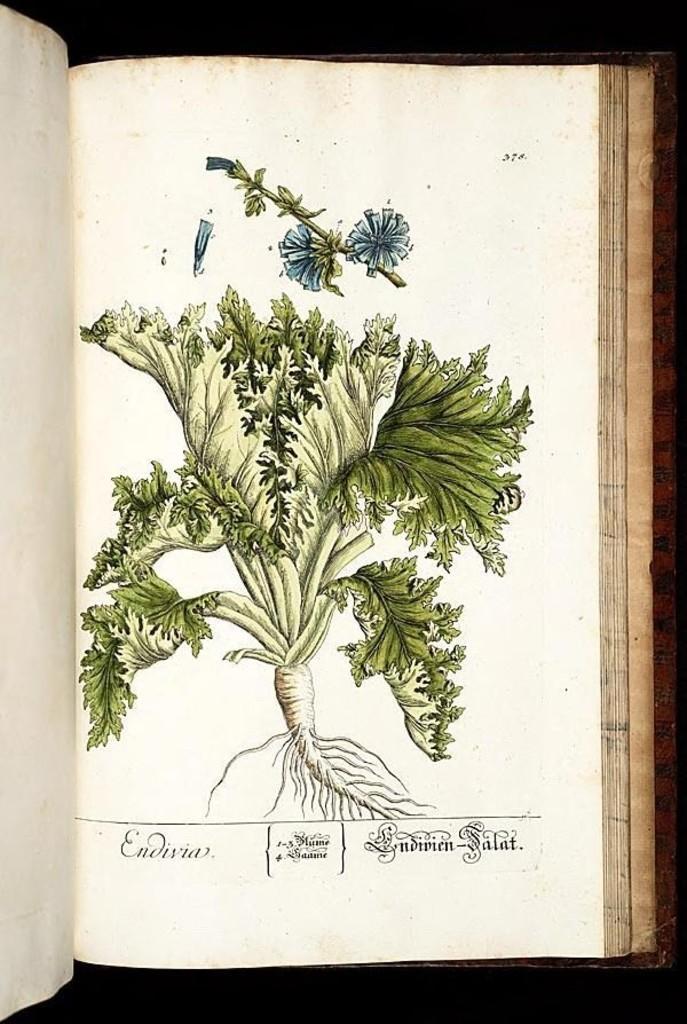Could you give a brief overview of what you see in this image? In the center of the image we can see painting of a plant in the book. 